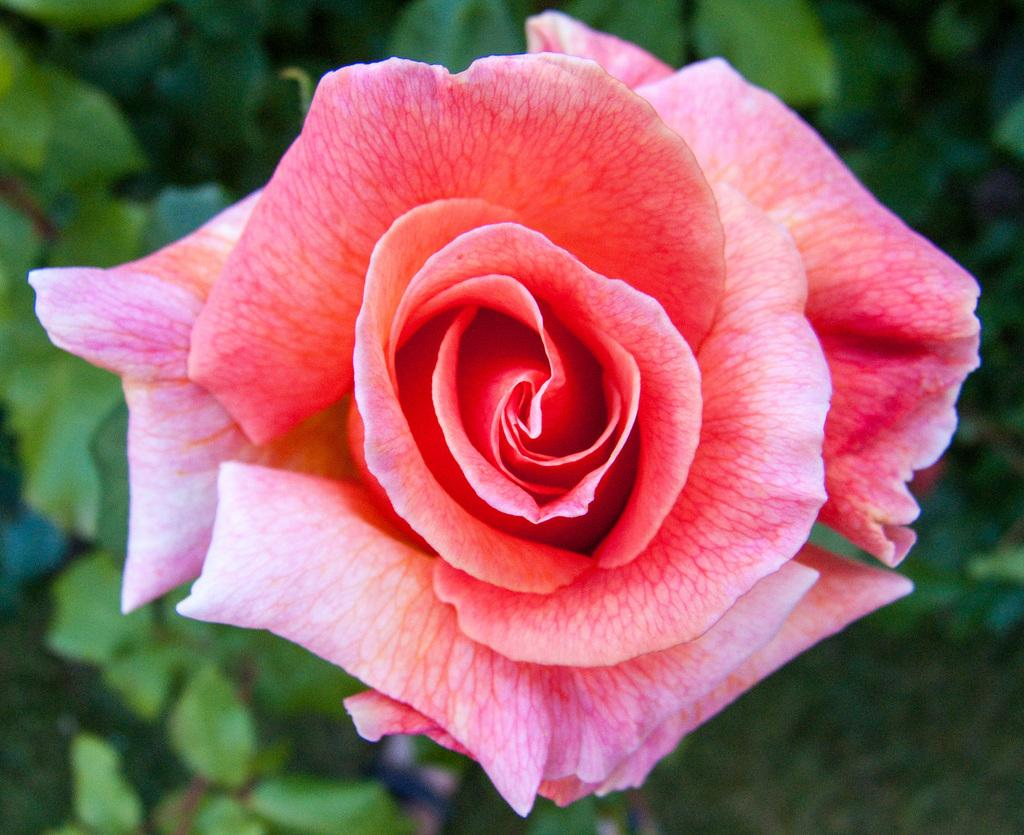What type of flower is in the image? There is a rose flower in the image. What can be seen in the background of the image? There are plants in the background of the image. What type of legal advice can be obtained from the rose flower in the image? The rose flower in the image is not a lawyer and cannot provide legal advice. 